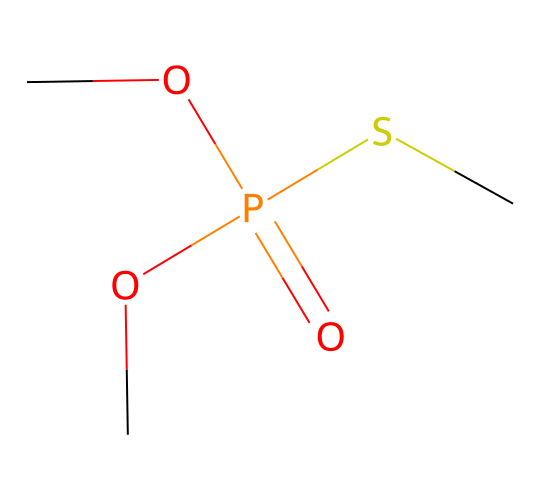What is the core functional group present in this chemical? The core functional group in this chemical is the phosphate group, which is indicated by the presence of the phosphorus atom bonded to oxygen atoms.
Answer: phosphate group How many carbon atoms are in this structure? The SMILES representation shows three carbon atoms (one denoted by "C" and two in "OC"), forming part of the molecule's backbone.
Answer: three What type of bonding is primarily represented in this molecule? The molecule exhibits covalent bonding, primarily between carbon, oxygen, and phosphorus atoms, as indicated by the connections in the SMILES structure.
Answer: covalent Does this chemical contain sulfur? Yes, the presence of "S" in the SMILES indicates that sulfur is part of the molecular structure.
Answer: yes What is the total number of oxygen atoms present in the molecule? The SMILES notation contains three oxygen atoms (one double-bonded to phosphorus and two connected to carbon), totaling three.
Answer: three Which part of the molecule is likely responsible for its toxicity? The phosphorus atom, part of the phosphate group, is commonly associated with the toxicity of organophosphate compounds due to their ability to inhibit enzymes that break down neurotransmitters.
Answer: phosphorus atom What class of pesticides does this chemical belong to? The structure represents an organophosphate pesticide due to the phosphate group, which is characteristic of this class.
Answer: organophosphate 